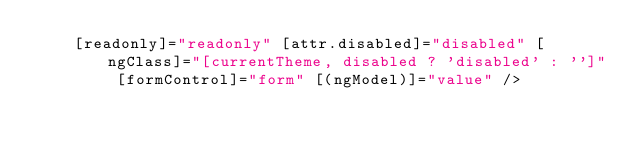Convert code to text. <code><loc_0><loc_0><loc_500><loc_500><_HTML_>    [readonly]="readonly" [attr.disabled]="disabled" [ngClass]="[currentTheme, disabled ? 'disabled' : '']" [formControl]="form" [(ngModel)]="value" /></code> 